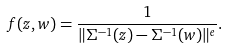<formula> <loc_0><loc_0><loc_500><loc_500>f ( z , w ) = \frac { 1 } { \| \Sigma ^ { - 1 } ( z ) - \Sigma ^ { - 1 } ( w ) \| ^ { e } } .</formula> 